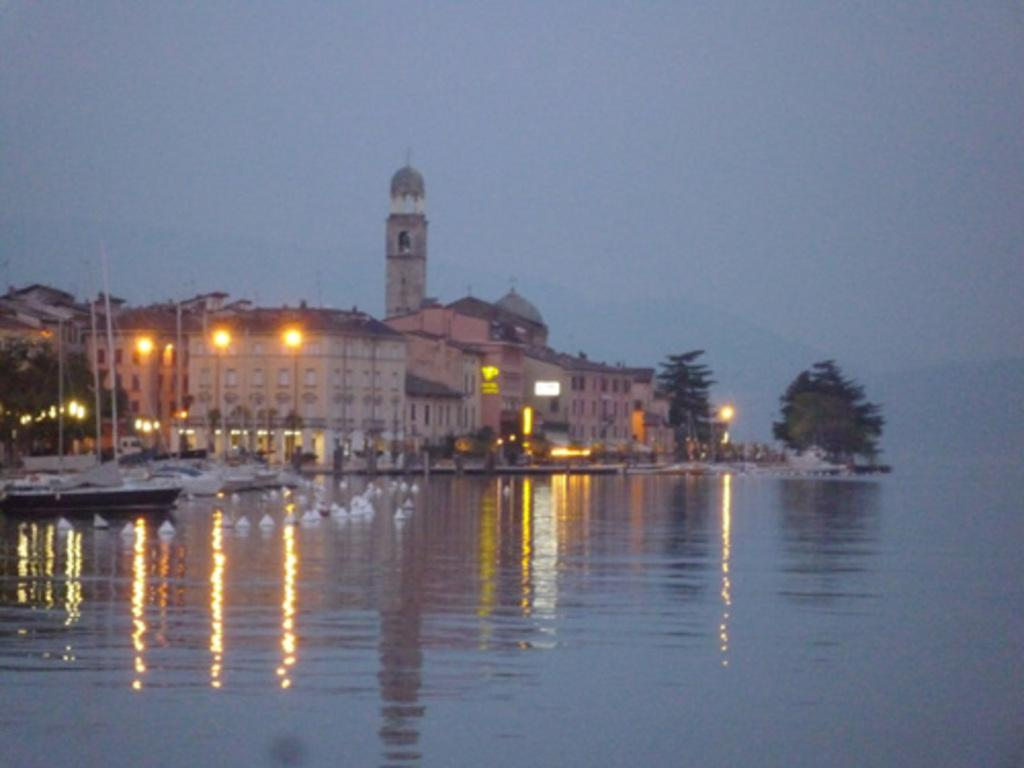What is in the foreground of the image? There is a water body in the foreground of the image. What can be seen on the left side of the image? There are boats and trees on the left side of the image. What is located in the center of the image? There are trees, lights, and a building in the center of the image. How would you describe the sky in the image? The sky is cloudy in the image. Can you read the letters on the stove in the image? There is no stove present in the image, so it is not possible to read any letters on it. 